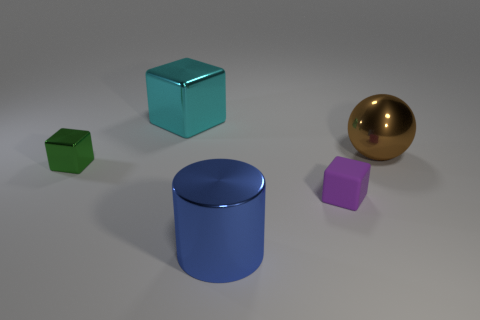Are there any other things that have the same material as the small purple cube?
Ensure brevity in your answer.  No. There is a purple object that is the same size as the green cube; what is its shape?
Your response must be concise. Cube. There is a small metal cube; are there any purple blocks behind it?
Your answer should be compact. No. Are there any shiny objects that are behind the tiny object on the left side of the blue shiny thing?
Offer a terse response. Yes. Are there fewer large cyan shiny blocks that are to the left of the cyan metal cube than purple matte objects in front of the tiny purple rubber cube?
Offer a terse response. No. Are there any other things that are the same size as the brown ball?
Provide a short and direct response. Yes. What is the shape of the green object?
Make the answer very short. Cube. There is a tiny thing on the left side of the cyan shiny thing; what material is it?
Offer a terse response. Metal. There is a metal thing to the right of the small object that is in front of the tiny block left of the purple matte thing; what size is it?
Your response must be concise. Large. Is the big cyan block behind the large brown sphere made of the same material as the thing in front of the tiny matte thing?
Offer a terse response. Yes. 